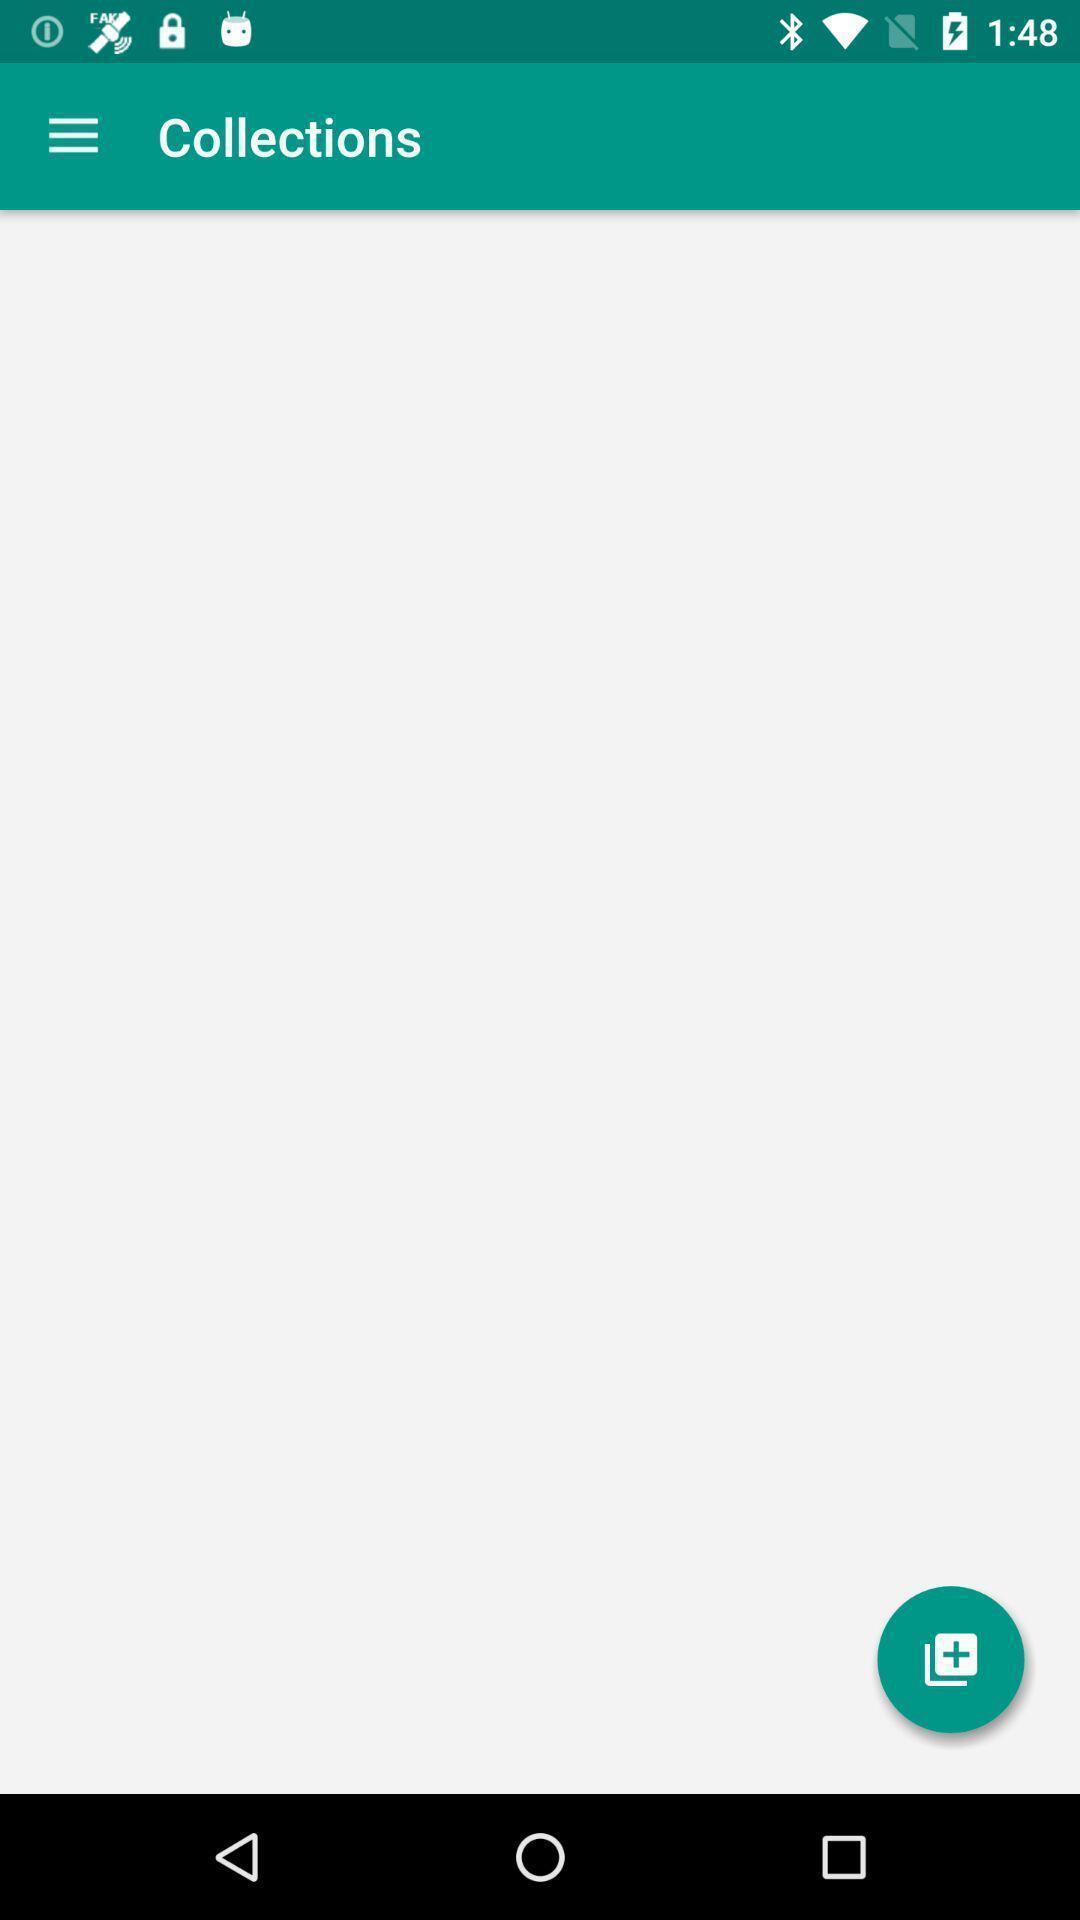Tell me what you see in this picture. Page displaying the screen of collection. 